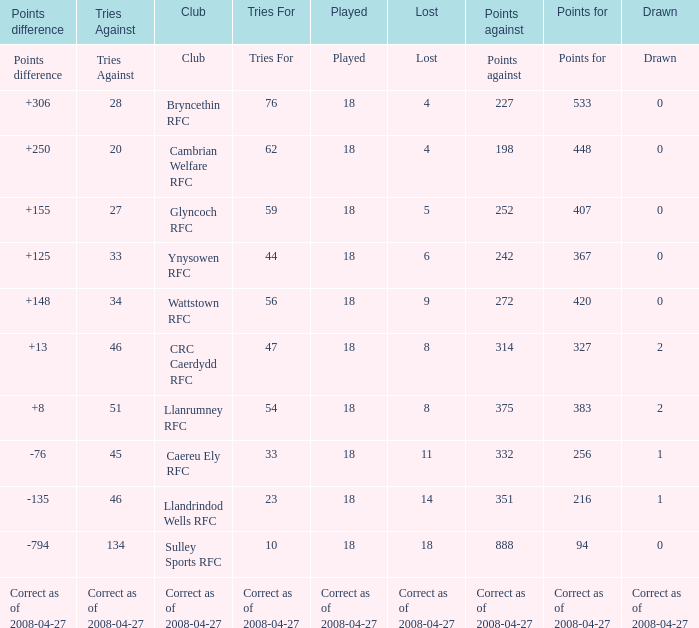Could you parse the entire table as a dict? {'header': ['Points difference', 'Tries Against', 'Club', 'Tries For', 'Played', 'Lost', 'Points against', 'Points for', 'Drawn'], 'rows': [['Points difference', 'Tries Against', 'Club', 'Tries For', 'Played', 'Lost', 'Points against', 'Points for', 'Drawn'], ['+306', '28', 'Bryncethin RFC', '76', '18', '4', '227', '533', '0'], ['+250', '20', 'Cambrian Welfare RFC', '62', '18', '4', '198', '448', '0'], ['+155', '27', 'Glyncoch RFC', '59', '18', '5', '252', '407', '0'], ['+125', '33', 'Ynysowen RFC', '44', '18', '6', '242', '367', '0'], ['+148', '34', 'Wattstown RFC', '56', '18', '9', '272', '420', '0'], ['+13', '46', 'CRC Caerdydd RFC', '47', '18', '8', '314', '327', '2'], ['+8', '51', 'Llanrumney RFC', '54', '18', '8', '375', '383', '2'], ['-76', '45', 'Caereu Ely RFC', '33', '18', '11', '332', '256', '1'], ['-135', '46', 'Llandrindod Wells RFC', '23', '18', '14', '351', '216', '1'], ['-794', '134', 'Sulley Sports RFC', '10', '18', '18', '888', '94', '0'], ['Correct as of 2008-04-27', 'Correct as of 2008-04-27', 'Correct as of 2008-04-27', 'Correct as of 2008-04-27', 'Correct as of 2008-04-27', 'Correct as of 2008-04-27', 'Correct as of 2008-04-27', 'Correct as of 2008-04-27', 'Correct as of 2008-04-27']]} What is the value of the item "Points" when the value of the item "Points against" is 272? 420.0. 